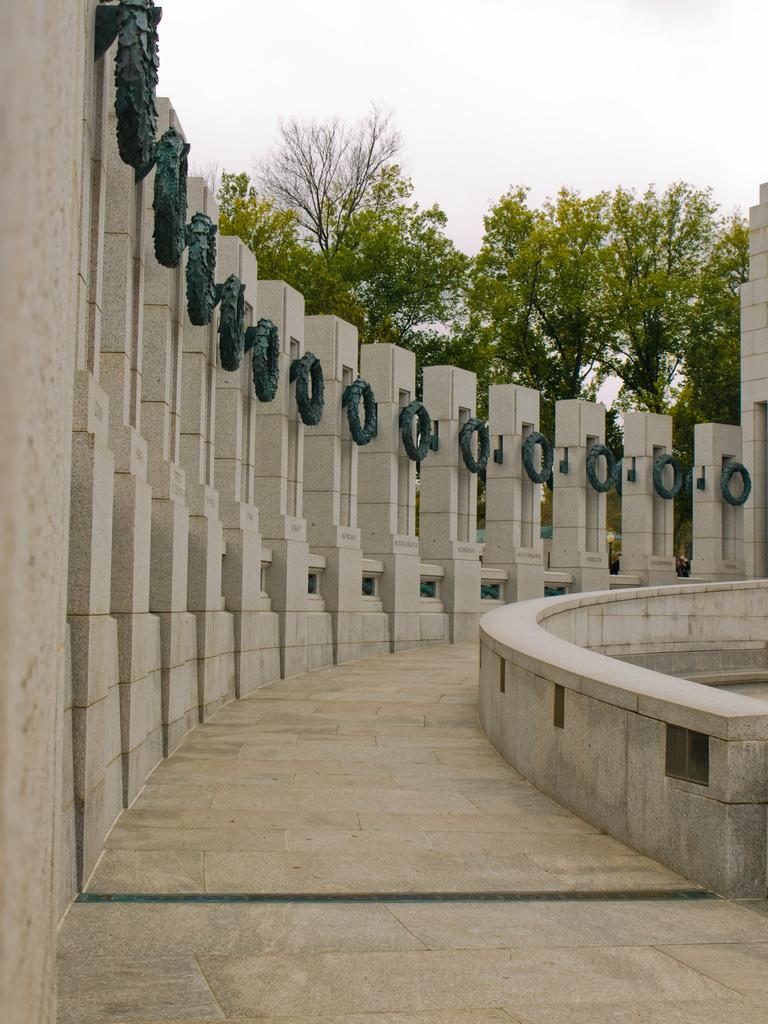What type of structures are visible in the image? There are buildings in the image. What can be seen in the middle of the image? There are trees in the middle of the image. What is visible at the top of the image? The sky is visible at the top of the image. What is the reason for the company's decision to plant trees in the image? There is no mention of a company or any decision-making process in the image, so it is not possible to answer this question. 